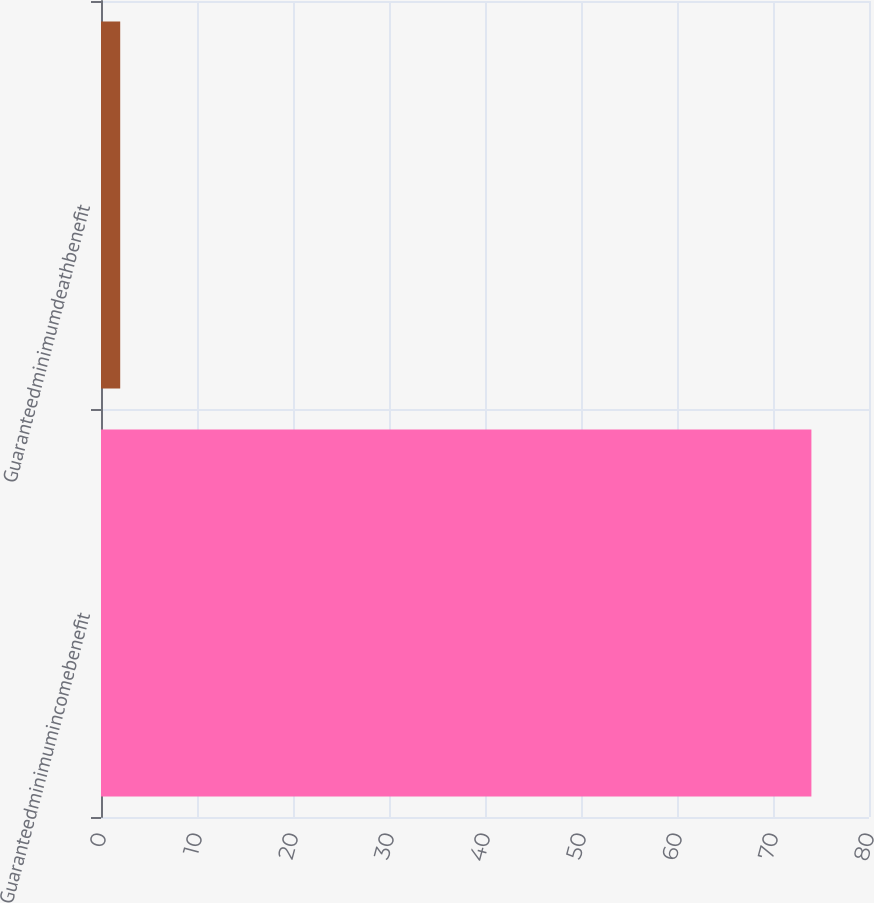<chart> <loc_0><loc_0><loc_500><loc_500><bar_chart><fcel>Guaranteedminimumincomebenefit<fcel>Guaranteedminimumdeathbenefit<nl><fcel>74<fcel>2<nl></chart> 